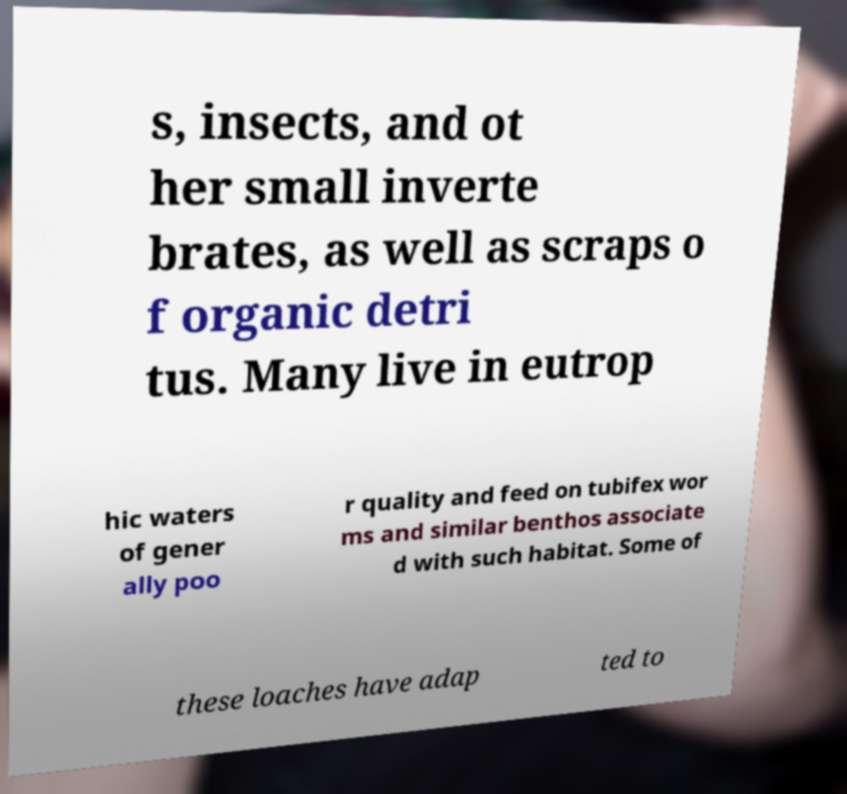Could you extract and type out the text from this image? s, insects, and ot her small inverte brates, as well as scraps o f organic detri tus. Many live in eutrop hic waters of gener ally poo r quality and feed on tubifex wor ms and similar benthos associate d with such habitat. Some of these loaches have adap ted to 